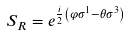Convert formula to latex. <formula><loc_0><loc_0><loc_500><loc_500>S _ { R } = e ^ { \frac { i } { 2 } \left ( \varphi \sigma ^ { 1 } - \theta \sigma ^ { 3 } \right ) }</formula> 